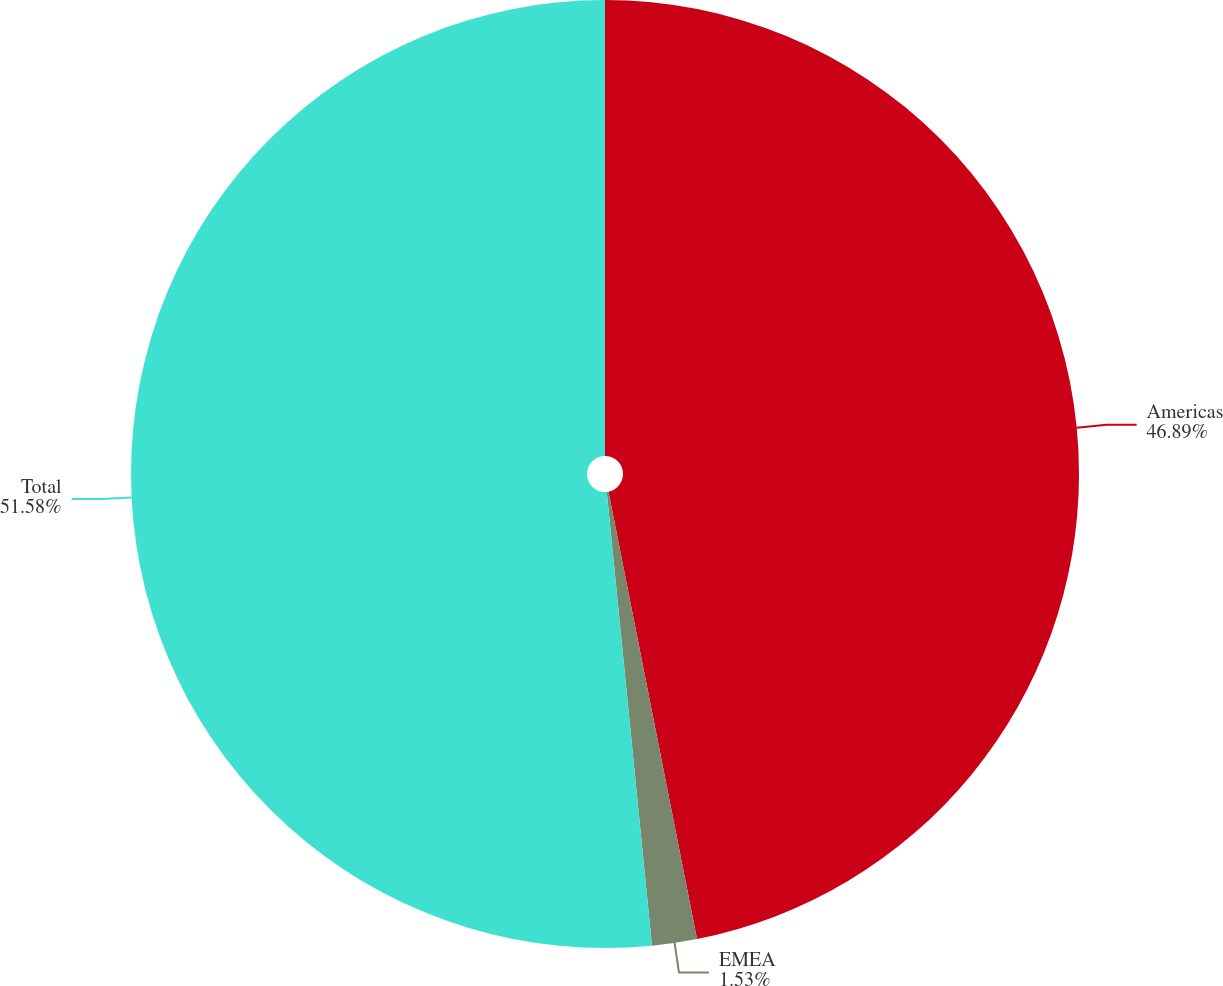<chart> <loc_0><loc_0><loc_500><loc_500><pie_chart><fcel>Americas<fcel>EMEA<fcel>Total<nl><fcel>46.89%<fcel>1.53%<fcel>51.58%<nl></chart> 